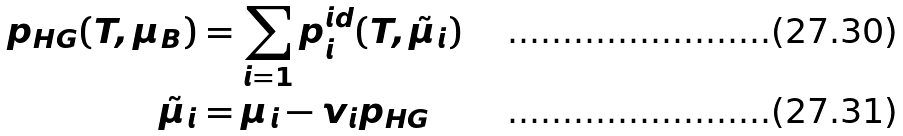<formula> <loc_0><loc_0><loc_500><loc_500>p _ { H G } ( T , \mu _ { B } ) & = \sum _ { i = 1 } p _ { i } ^ { i d } ( T , \tilde { \mu } _ { i } ) \\ \tilde { \mu } _ { i } & = \mu _ { i } - v _ { i } p _ { H G }</formula> 